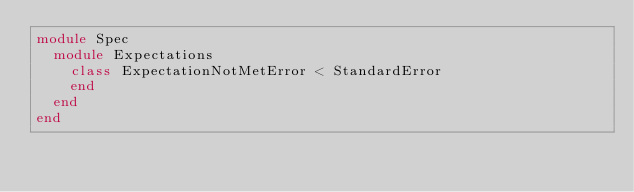Convert code to text. <code><loc_0><loc_0><loc_500><loc_500><_Ruby_>module Spec
  module Expectations
    class ExpectationNotMetError < StandardError
    end
  end
end
</code> 